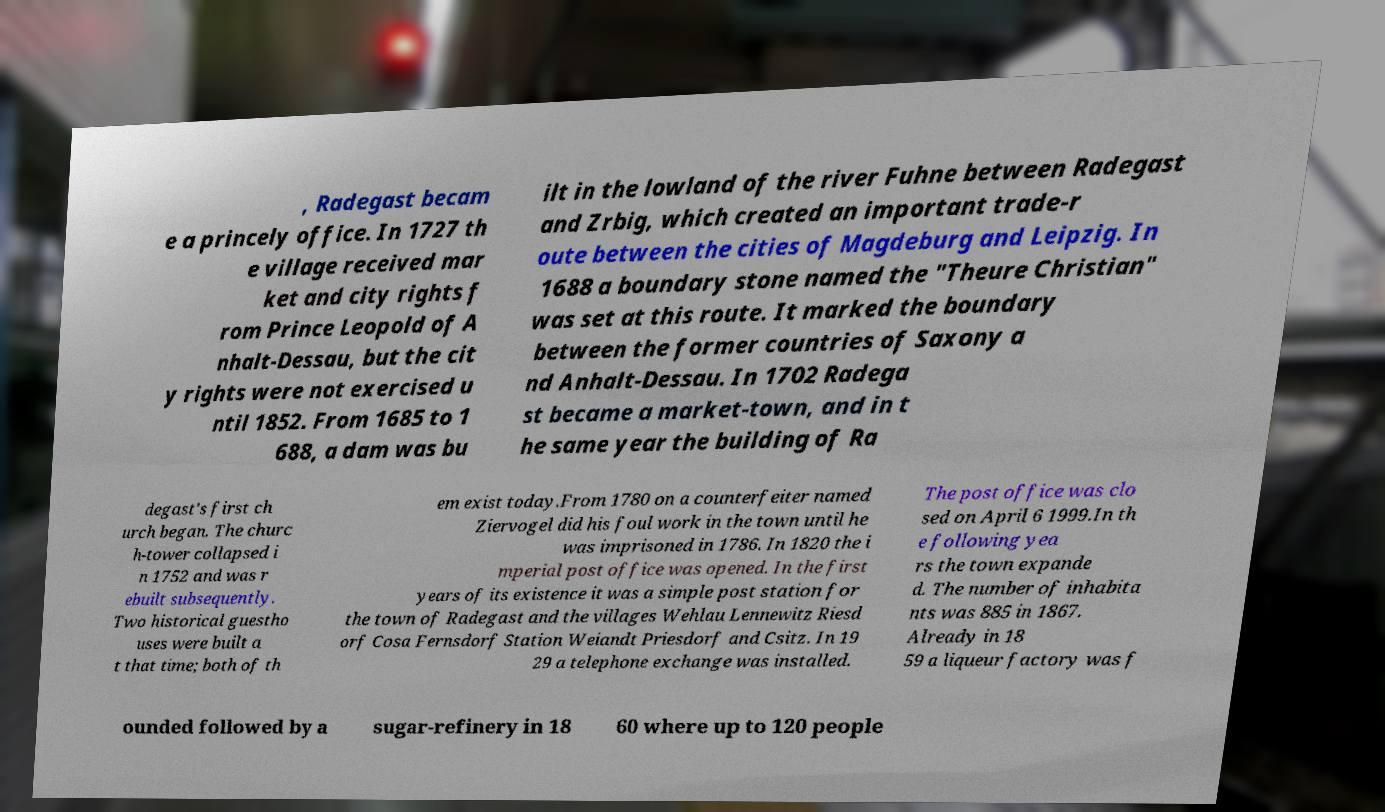Could you extract and type out the text from this image? , Radegast becam e a princely office. In 1727 th e village received mar ket and city rights f rom Prince Leopold of A nhalt-Dessau, but the cit y rights were not exercised u ntil 1852. From 1685 to 1 688, a dam was bu ilt in the lowland of the river Fuhne between Radegast and Zrbig, which created an important trade-r oute between the cities of Magdeburg and Leipzig. In 1688 a boundary stone named the "Theure Christian" was set at this route. It marked the boundary between the former countries of Saxony a nd Anhalt-Dessau. In 1702 Radega st became a market-town, and in t he same year the building of Ra degast's first ch urch began. The churc h-tower collapsed i n 1752 and was r ebuilt subsequently. Two historical guestho uses were built a t that time; both of th em exist today.From 1780 on a counterfeiter named Ziervogel did his foul work in the town until he was imprisoned in 1786. In 1820 the i mperial post office was opened. In the first years of its existence it was a simple post station for the town of Radegast and the villages Wehlau Lennewitz Riesd orf Cosa Fernsdorf Station Weiandt Priesdorf and Csitz. In 19 29 a telephone exchange was installed. The post office was clo sed on April 6 1999.In th e following yea rs the town expande d. The number of inhabita nts was 885 in 1867. Already in 18 59 a liqueur factory was f ounded followed by a sugar-refinery in 18 60 where up to 120 people 